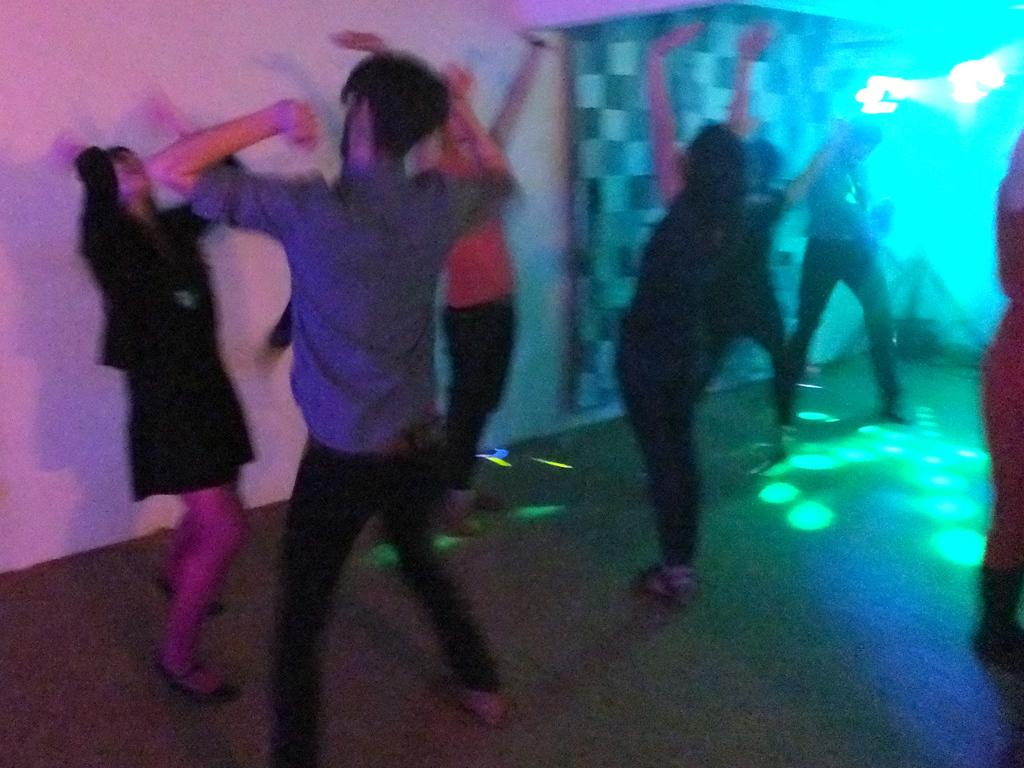Who or what is present in the image? There are people in the image. What are the people doing in the image? The people are dancing. Are there any additional elements in the image besides the people? Yes, there are colorful lights in the image. Can you see any wounds on the people in the image? There is no indication of any wounds on the people in the image. What type of coal is being used to fuel the tank in the image? There is no tank or coal present in the image. 